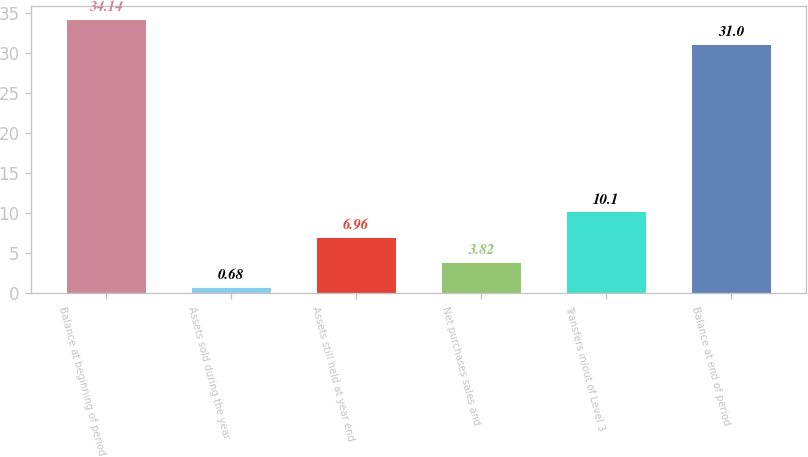Convert chart to OTSL. <chart><loc_0><loc_0><loc_500><loc_500><bar_chart><fcel>Balance at beginning of period<fcel>Assets sold during the year<fcel>Assets still held at year end<fcel>Net purchases sales and<fcel>Transfers in/out of Level 3<fcel>Balance at end of period<nl><fcel>34.14<fcel>0.68<fcel>6.96<fcel>3.82<fcel>10.1<fcel>31<nl></chart> 